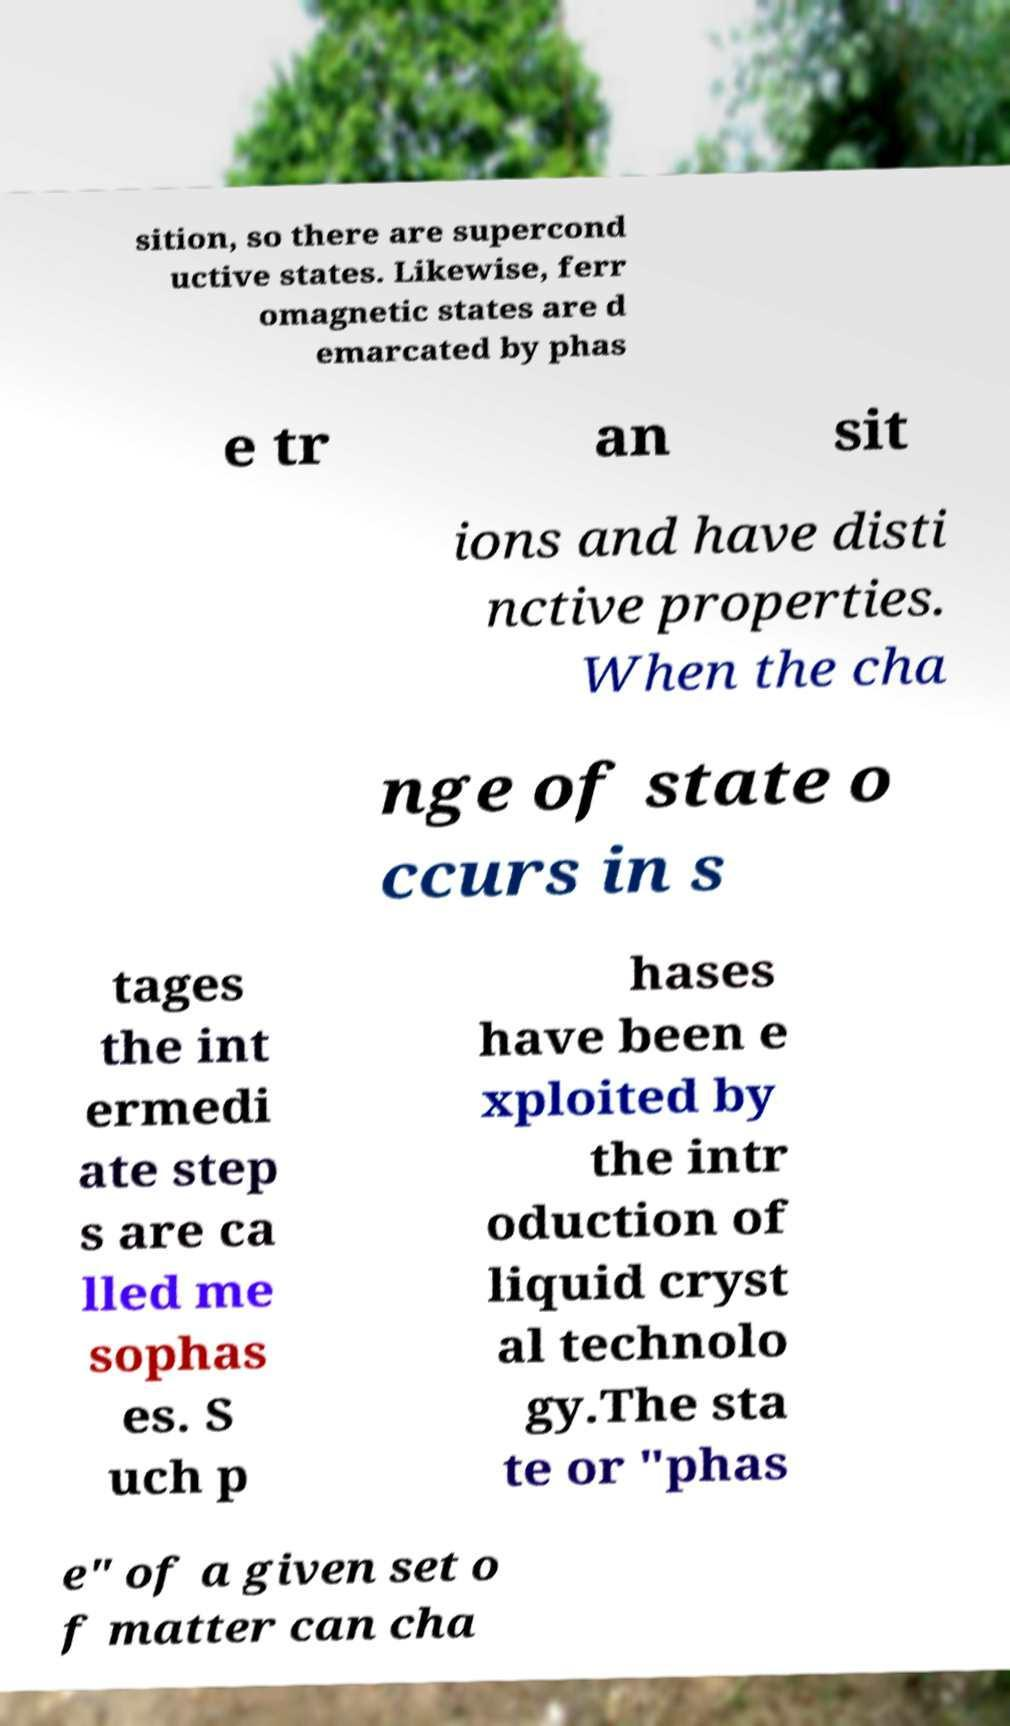Can you read and provide the text displayed in the image?This photo seems to have some interesting text. Can you extract and type it out for me? sition, so there are supercond uctive states. Likewise, ferr omagnetic states are d emarcated by phas e tr an sit ions and have disti nctive properties. When the cha nge of state o ccurs in s tages the int ermedi ate step s are ca lled me sophas es. S uch p hases have been e xploited by the intr oduction of liquid cryst al technolo gy.The sta te or "phas e" of a given set o f matter can cha 